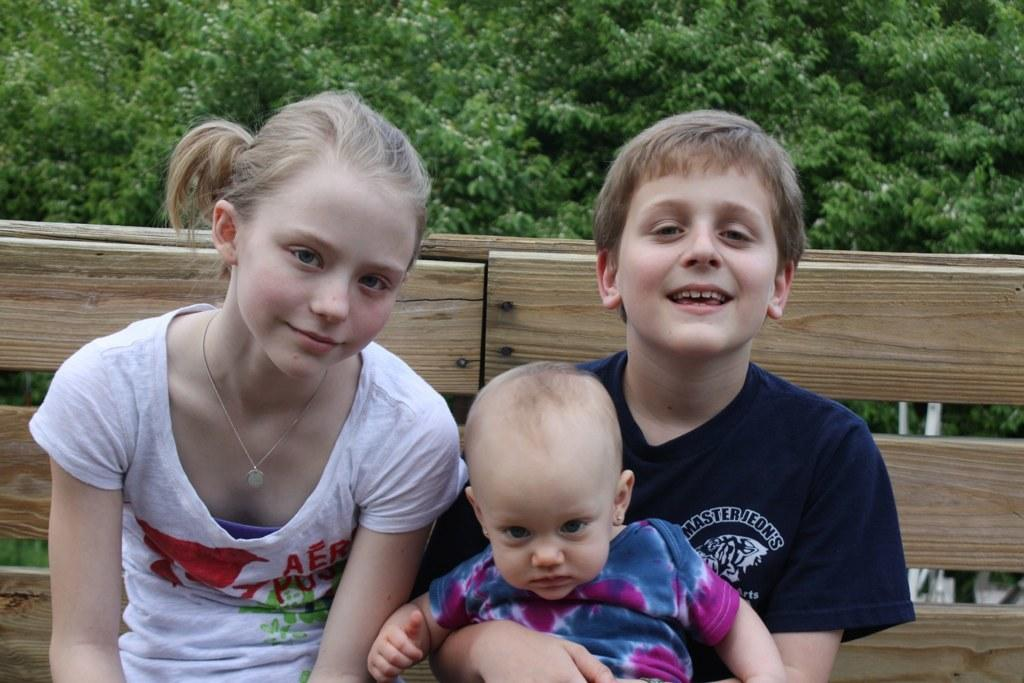What are the people in the image doing? The people in the image are sitting on a wooden bench. What can be seen in the background of the image? There are trees visible in the image. What color are the objects mentioned in the image? The white-colored objects are present in the image. What type of order is the fireman giving in the image? There is no fireman present in the image, and therefore no order can be given. 